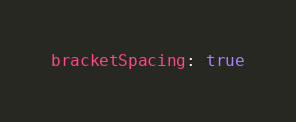<code> <loc_0><loc_0><loc_500><loc_500><_YAML_>bracketSpacing: true
</code> 